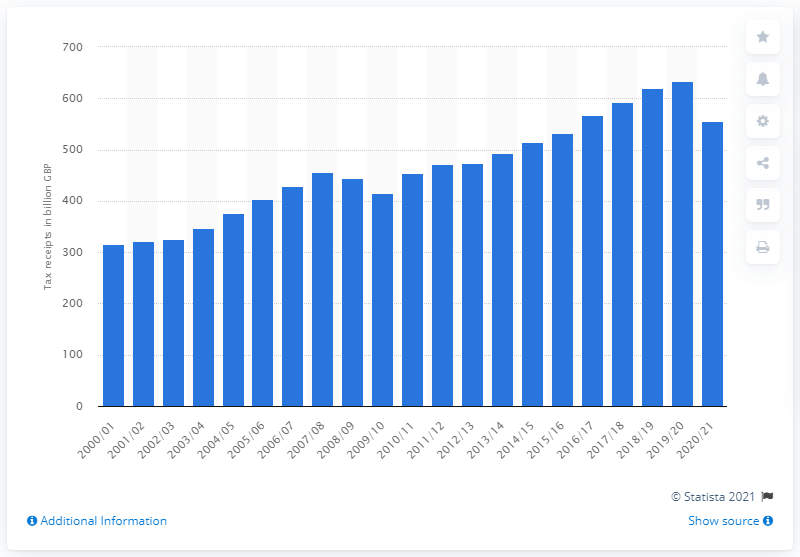Identify some key points in this picture. In the 2020/21 financial year, the total value of HMRC tax receipts for the United Kingdom was 556.01. 